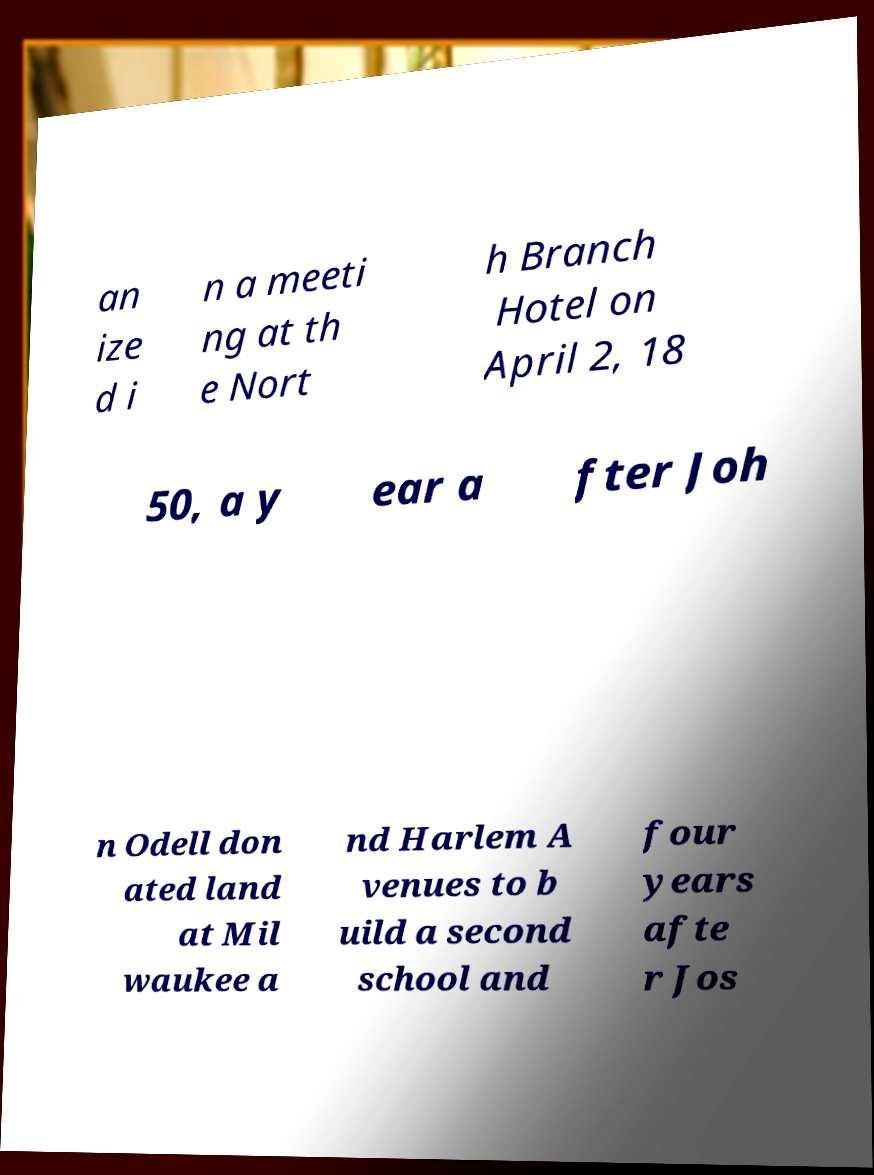For documentation purposes, I need the text within this image transcribed. Could you provide that? an ize d i n a meeti ng at th e Nort h Branch Hotel on April 2, 18 50, a y ear a fter Joh n Odell don ated land at Mil waukee a nd Harlem A venues to b uild a second school and four years afte r Jos 